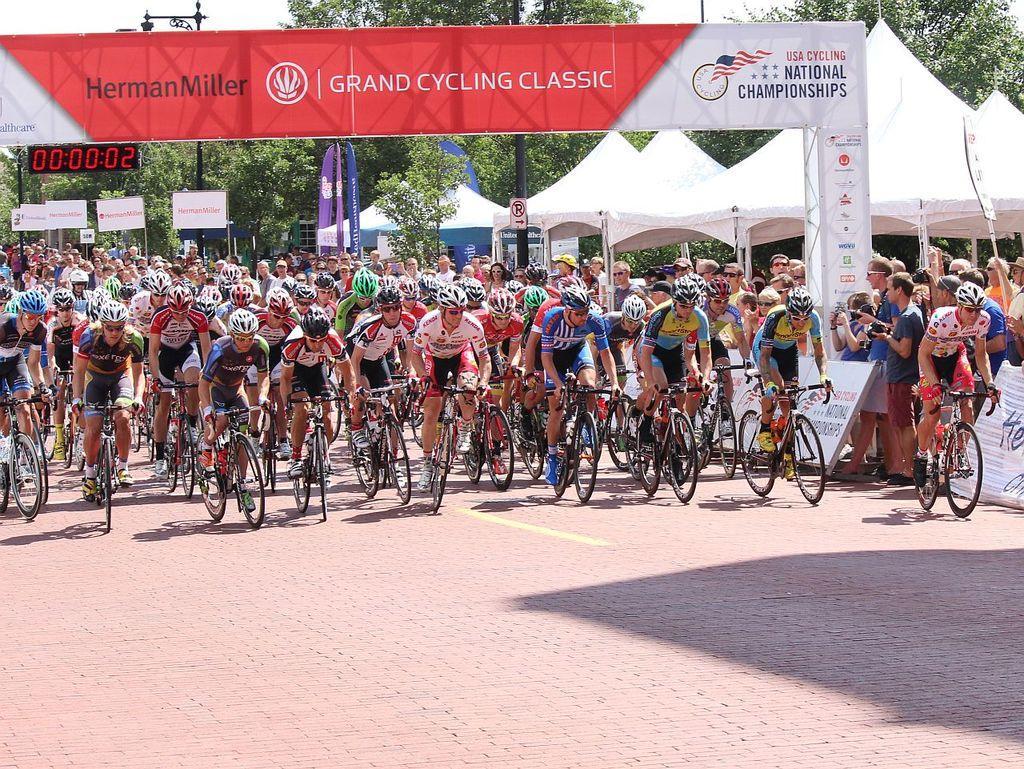In one or two sentences, can you explain what this image depicts? In this image, we can see the ground. There are a few people. Among them, some people are riding bicycles. We can see some boards with text. We can see some banners. We can see a hoarding with some image and text. There are a few poles, trees. We can also see a signboard. We can see the sky. We can see some tents. 